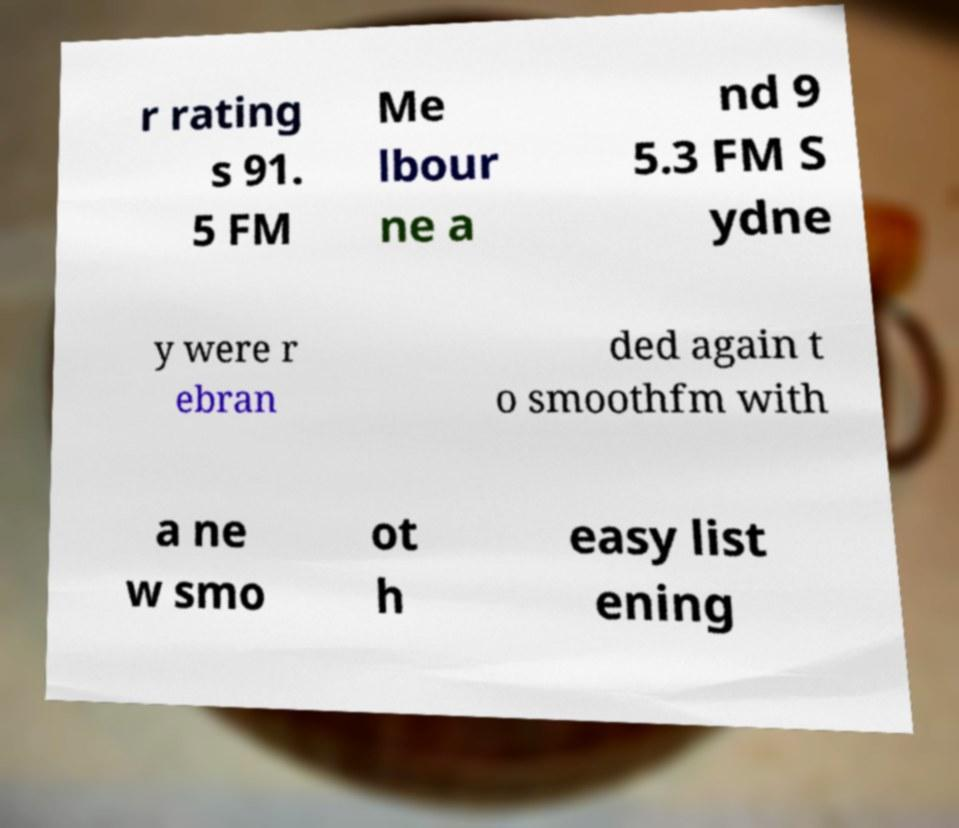I need the written content from this picture converted into text. Can you do that? r rating s 91. 5 FM Me lbour ne a nd 9 5.3 FM S ydne y were r ebran ded again t o smoothfm with a ne w smo ot h easy list ening 